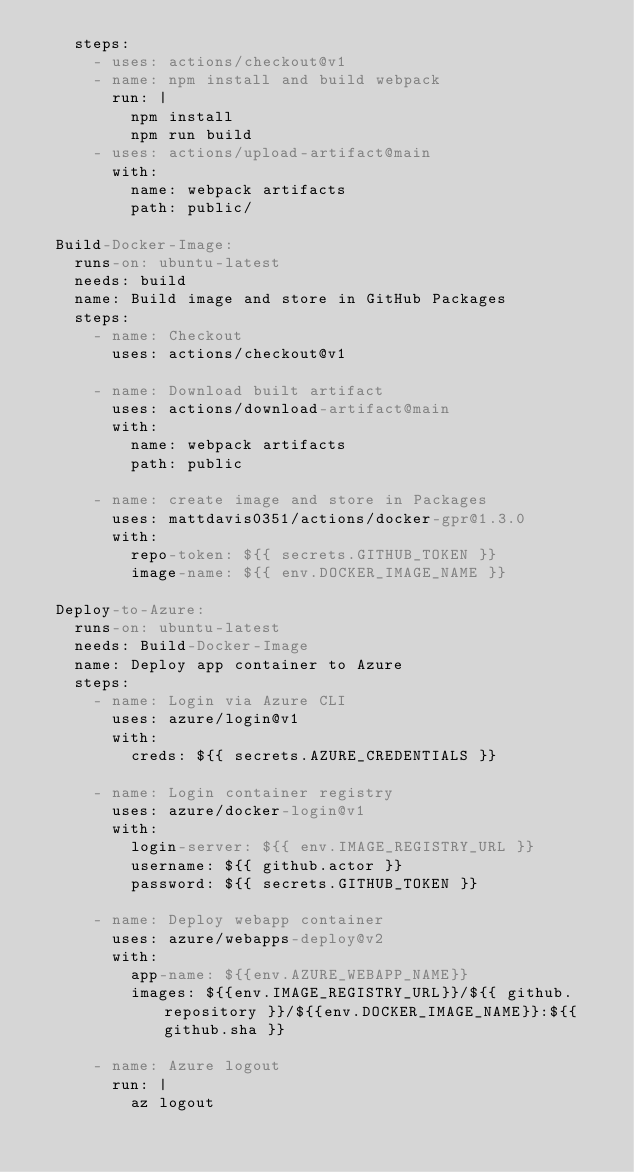<code> <loc_0><loc_0><loc_500><loc_500><_YAML_>    steps:
      - uses: actions/checkout@v1
      - name: npm install and build webpack
        run: |
          npm install
          npm run build
      - uses: actions/upload-artifact@main
        with:
          name: webpack artifacts
          path: public/
          
  Build-Docker-Image:
    runs-on: ubuntu-latest
    needs: build
    name: Build image and store in GitHub Packages
    steps:
      - name: Checkout
        uses: actions/checkout@v1
        
      - name: Download built artifact
        uses: actions/download-artifact@main
        with:
          name: webpack artifacts
          path: public
          
      - name: create image and store in Packages
        uses: mattdavis0351/actions/docker-gpr@1.3.0
        with:
          repo-token: ${{ secrets.GITHUB_TOKEN }}
          image-name: ${{ env.DOCKER_IMAGE_NAME }}
          
  Deploy-to-Azure:
    runs-on: ubuntu-latest
    needs: Build-Docker-Image
    name: Deploy app container to Azure
    steps:
      - name: Login via Azure CLI
        uses: azure/login@v1
        with:
          creds: ${{ secrets.AZURE_CREDENTIALS }}
  
      - name: Login container registry
        uses: azure/docker-login@v1
        with:
          login-server: ${{ env.IMAGE_REGISTRY_URL }}
          username: ${{ github.actor }}
          password: ${{ secrets.GITHUB_TOKEN }}
          
      - name: Deploy webapp container
        uses: azure/webapps-deploy@v2
        with:
          app-name: ${{env.AZURE_WEBAPP_NAME}}
          images: ${{env.IMAGE_REGISTRY_URL}}/${{ github.repository }}/${{env.DOCKER_IMAGE_NAME}}:${{ github.sha }}
          
      - name: Azure logout
        run: |
          az logout
          
          
</code> 